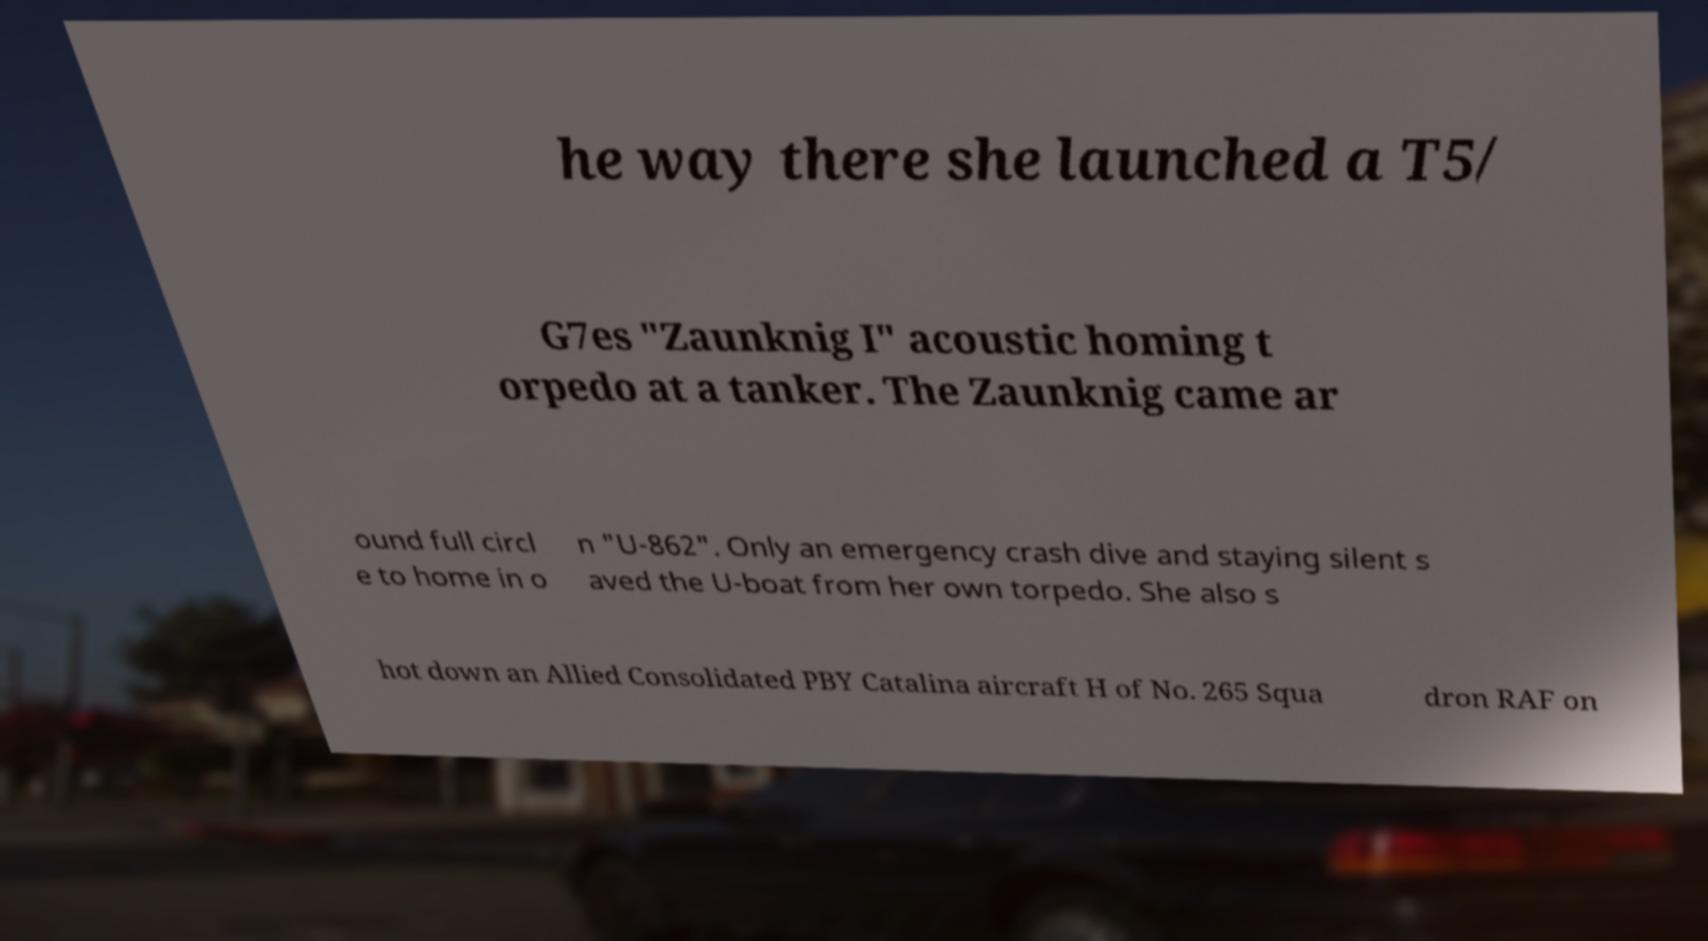Please identify and transcribe the text found in this image. he way there she launched a T5/ G7es "Zaunknig I" acoustic homing t orpedo at a tanker. The Zaunknig came ar ound full circl e to home in o n "U-862". Only an emergency crash dive and staying silent s aved the U-boat from her own torpedo. She also s hot down an Allied Consolidated PBY Catalina aircraft H of No. 265 Squa dron RAF on 